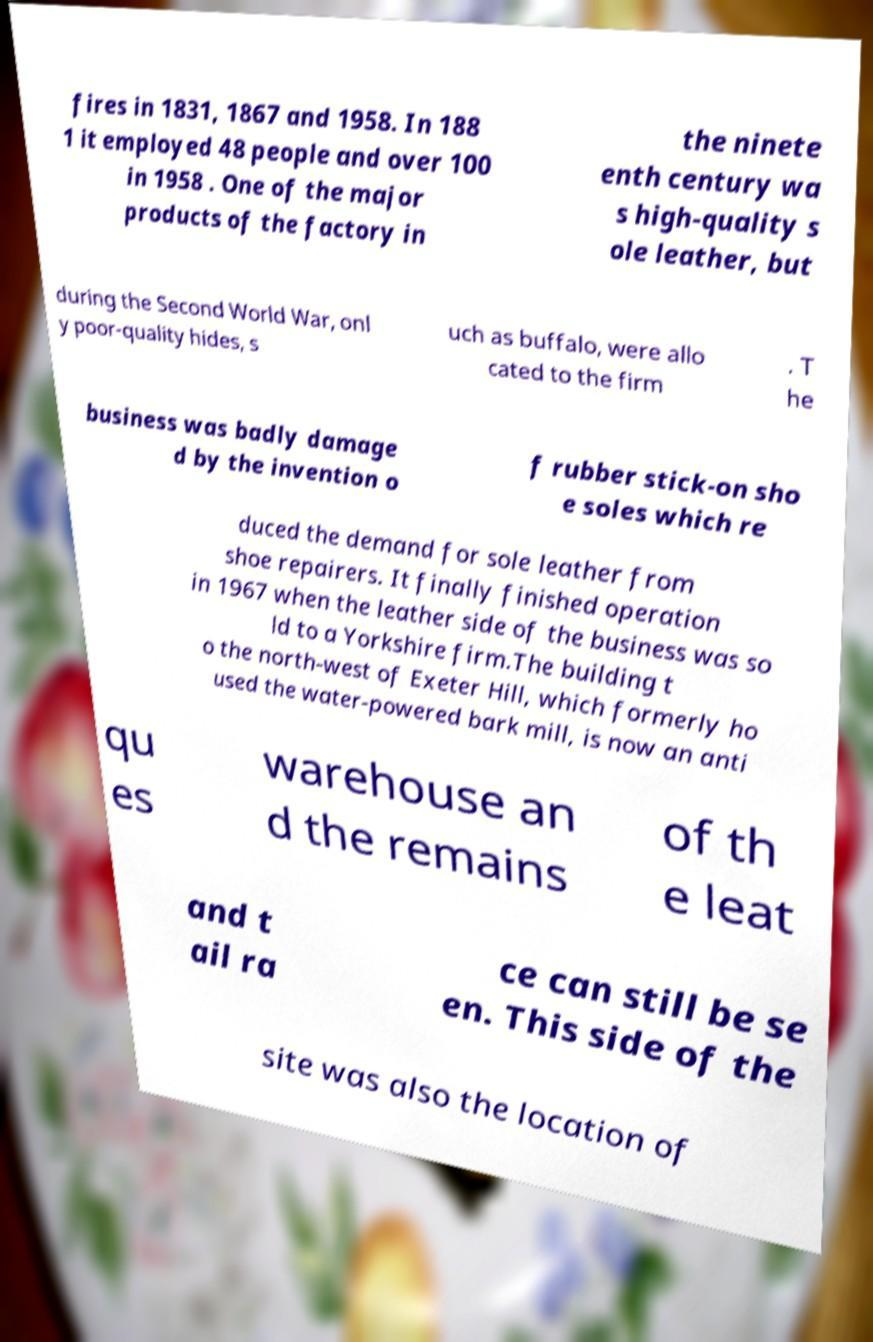Could you assist in decoding the text presented in this image and type it out clearly? fires in 1831, 1867 and 1958. In 188 1 it employed 48 people and over 100 in 1958 . One of the major products of the factory in the ninete enth century wa s high-quality s ole leather, but during the Second World War, onl y poor-quality hides, s uch as buffalo, were allo cated to the firm . T he business was badly damage d by the invention o f rubber stick-on sho e soles which re duced the demand for sole leather from shoe repairers. It finally finished operation in 1967 when the leather side of the business was so ld to a Yorkshire firm.The building t o the north-west of Exeter Hill, which formerly ho used the water-powered bark mill, is now an anti qu es warehouse an d the remains of th e leat and t ail ra ce can still be se en. This side of the site was also the location of 